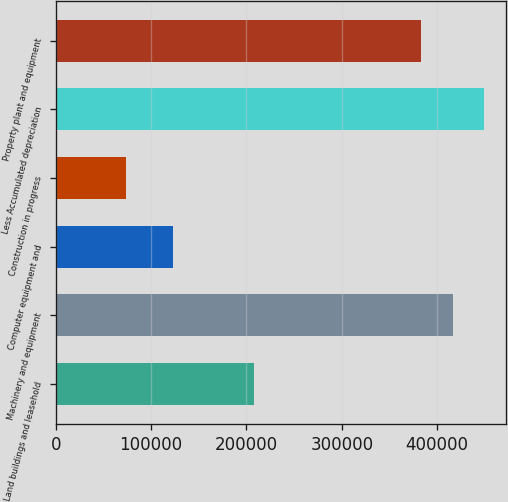Convert chart to OTSL. <chart><loc_0><loc_0><loc_500><loc_500><bar_chart><fcel>Land buildings and leasehold<fcel>Machinery and equipment<fcel>Computer equipment and<fcel>Construction in progress<fcel>Less Accumulated depreciation<fcel>Property plant and equipment<nl><fcel>207927<fcel>416252<fcel>122890<fcel>73920<fcel>449505<fcel>382999<nl></chart> 